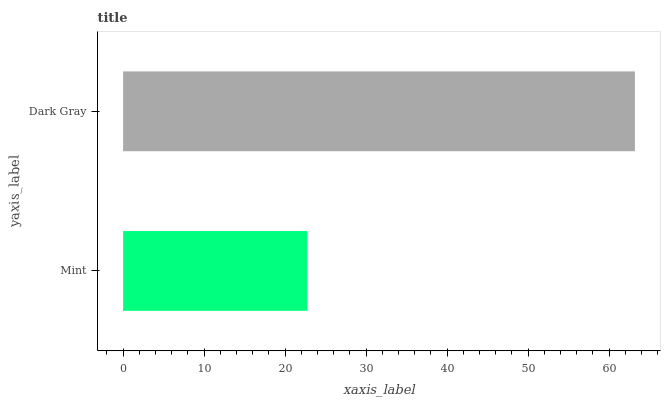Is Mint the minimum?
Answer yes or no. Yes. Is Dark Gray the maximum?
Answer yes or no. Yes. Is Dark Gray the minimum?
Answer yes or no. No. Is Dark Gray greater than Mint?
Answer yes or no. Yes. Is Mint less than Dark Gray?
Answer yes or no. Yes. Is Mint greater than Dark Gray?
Answer yes or no. No. Is Dark Gray less than Mint?
Answer yes or no. No. Is Dark Gray the high median?
Answer yes or no. Yes. Is Mint the low median?
Answer yes or no. Yes. Is Mint the high median?
Answer yes or no. No. Is Dark Gray the low median?
Answer yes or no. No. 